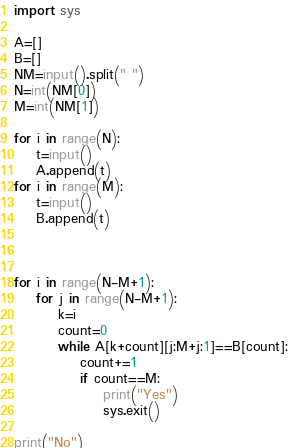Convert code to text. <code><loc_0><loc_0><loc_500><loc_500><_Python_>import sys

A=[]
B=[]
NM=input().split(" ")
N=int(NM[0])
M=int(NM[1])

for i in range(N):
    t=input()
    A.append(t)
for i in range(M):
    t=input()
    B.append(t)



for i in range(N-M+1):
    for j in range(N-M+1):
        k=i
        count=0
        while A[k+count][j:M+j:1]==B[count]:
            count+=1
            if count==M:
                print("Yes")
                sys.exit()

print("No")
</code> 